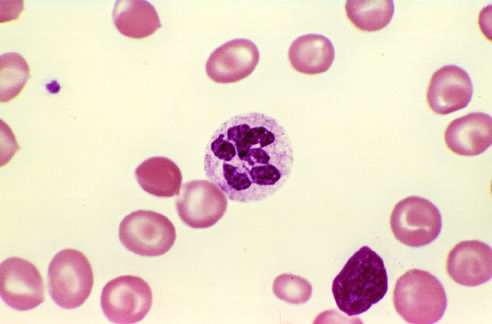does a peripheral blood smear show a hyper-segmented neutrophil with a six-lobed nucleus?
Answer the question using a single word or phrase. Yes 